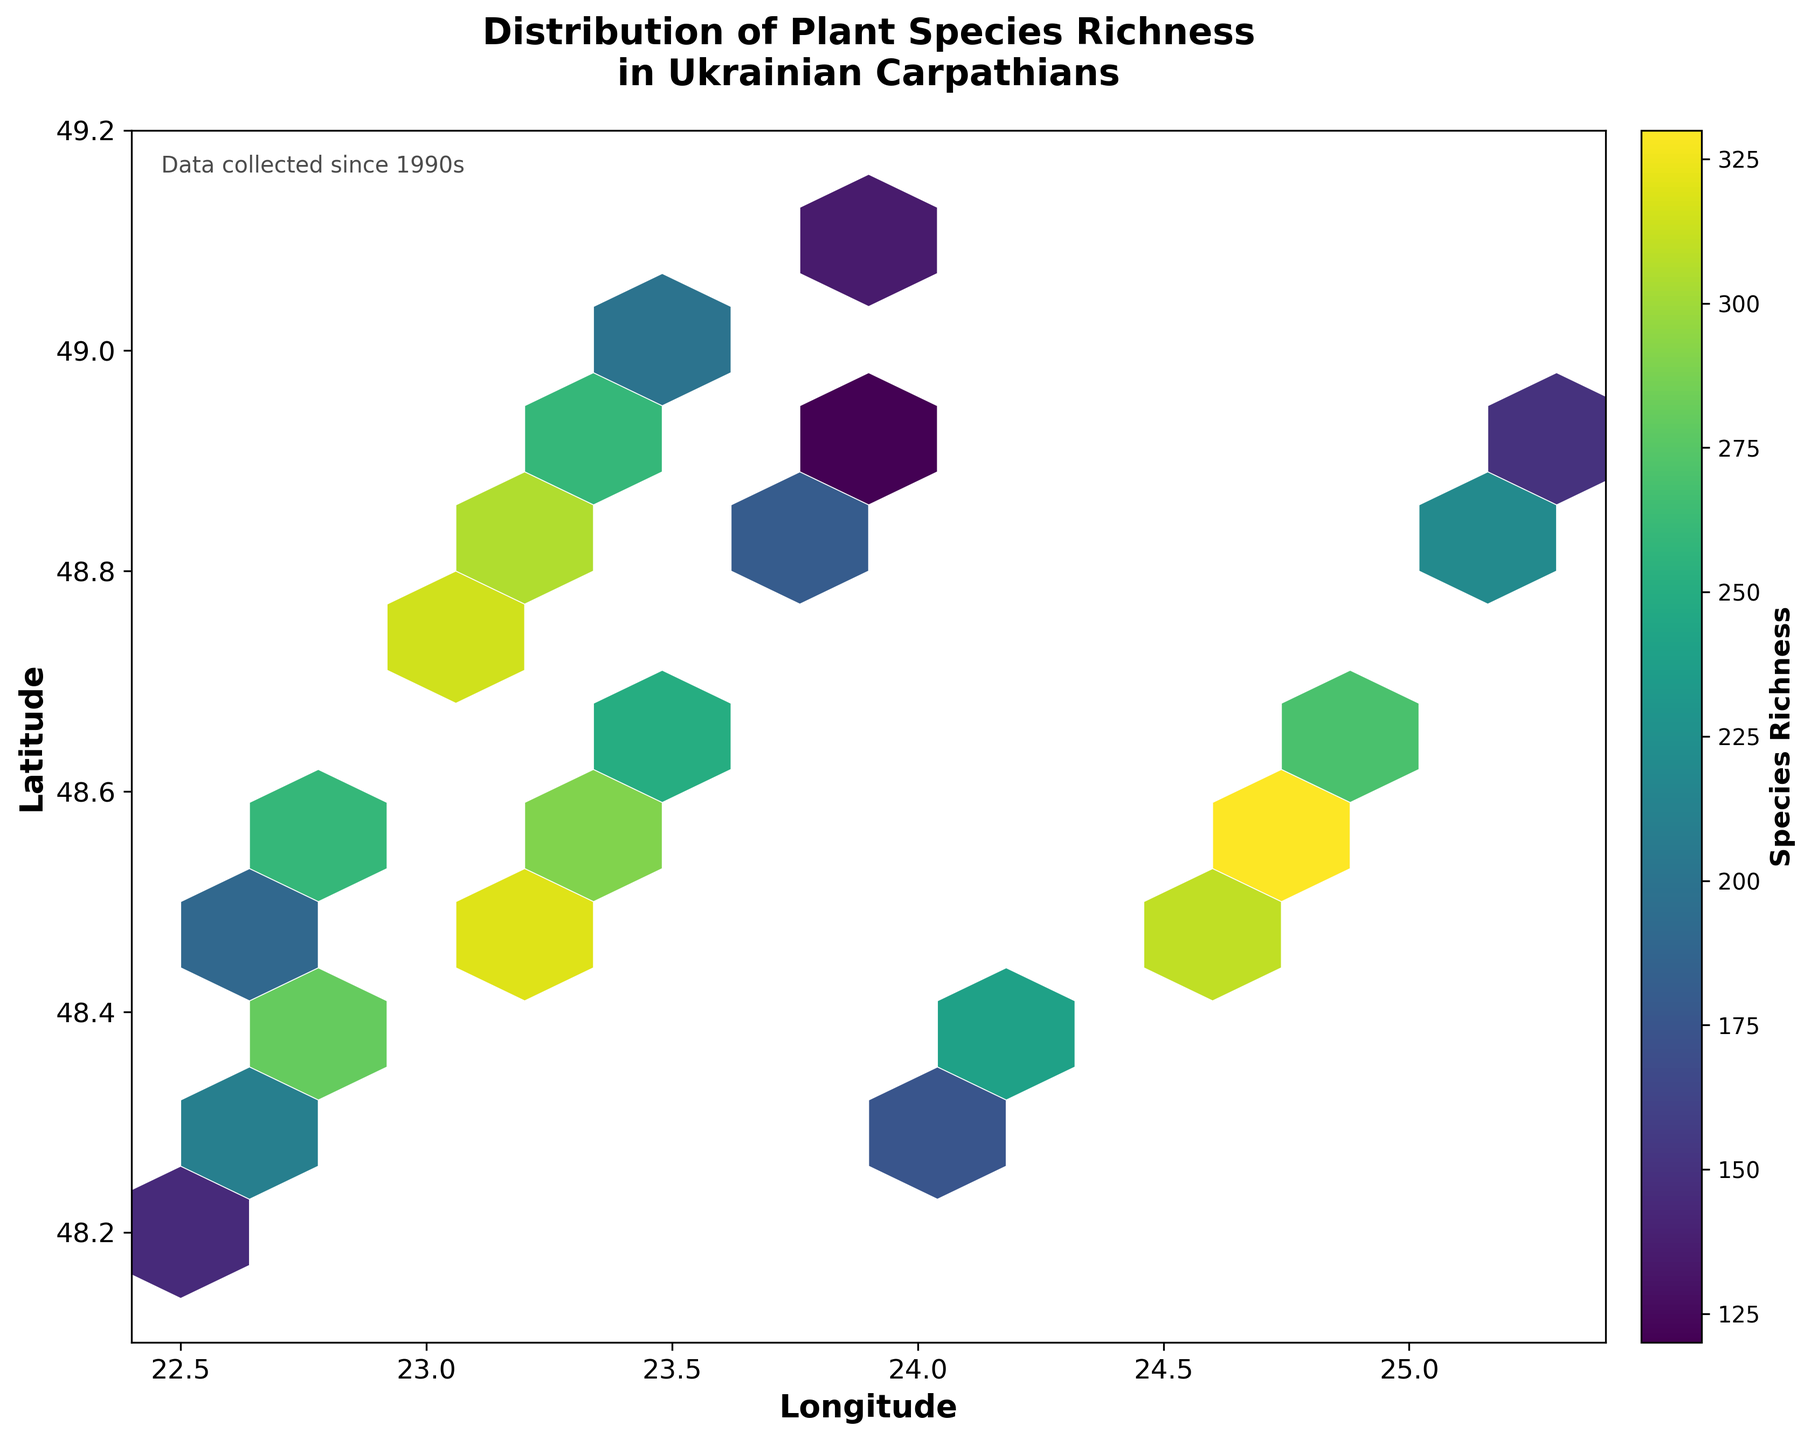What is the title of the plot? The title of the plot is prominently displayed at the top of the figure.
Answer: Distribution of Plant Species Richness in Ukrainian Carpathians Which axis represents the longitude? The x-axis represents the longitude, as indicated by the "Longitude" label below the horizontal line.
Answer: The x-axis What color scheme is used in the plot? The color scheme used is "viridis," which ranges from dark blue to bright yellow.
Answer: Viridis How many sections does the figure divide the latitude into? The figure's latitude ranges from 48.1 to 49.2, and the hexbin plot divides it into grid sections.
Answer: 11 sections Which area - northeastern or southwestern - shows higher species richness? Typically, richer species areas show brighter colors (yellow). By visually comparing the northeast and southwest areas, one can determine higher species richness.
Answer: Northeastern area What is the color of the area with the lowest species richness? The color associated with the lowest species richness in the viridis color scheme is dark blue.
Answer: Dark blue What color indicates areas with maximum species richness, and where are these areas located? The brightest color, yellow, indicates areas with the highest species richness. These areas are mostly located in the northeastern part of the plot.
Answer: Yellow; Northeastern part Considering the species richness trend, does species richness generally increase or decrease with altitude? The areas plotted show the species richness trends over altitude, with a noticeable gradient from high to low species richness as you move to higher altitudes.
Answer: Decrease In which range of longitude do you find the highest species richness? By examining the vertical bands of yellow in the plot, one can determine the range of longitude with the highest species richness.
Answer: 23.0 to 24.0 Explain how species richness varies between the coordinates (22.5, 48.2) and (24.5, 48.5). The hexbin plot shows species richness using color gradations. Comparing the color at (22.5, 48.2) and (24.5, 48.5) reveals the difference in species richness. The former has lower richness (darker blue) while the latter has higher richness (brighter yellow).
Answer: Higher at (24.5, 48.5) 